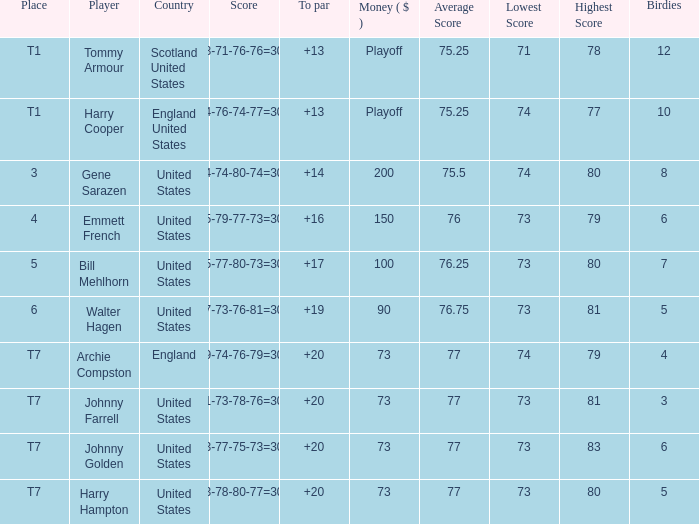What is the ranking for the United States when the money is $200? 3.0. 